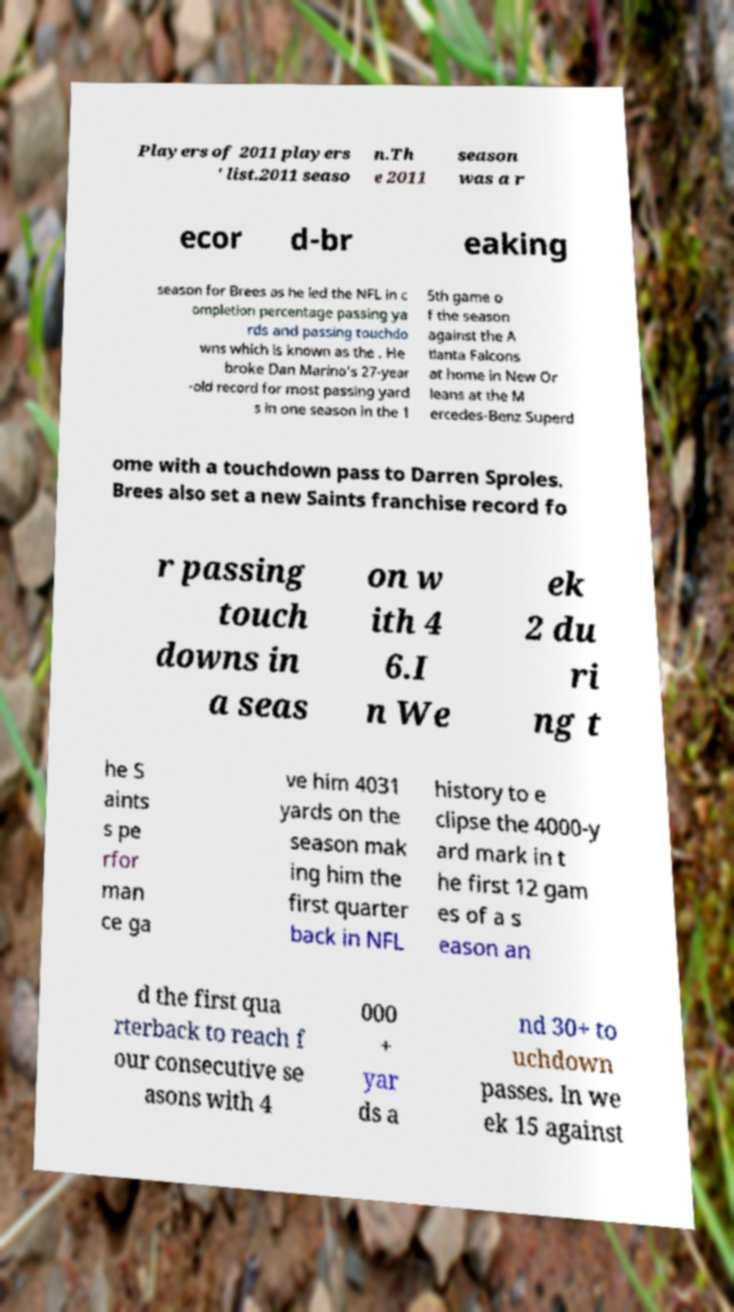What messages or text are displayed in this image? I need them in a readable, typed format. Players of 2011 players ' list.2011 seaso n.Th e 2011 season was a r ecor d-br eaking season for Brees as he led the NFL in c ompletion percentage passing ya rds and passing touchdo wns which is known as the . He broke Dan Marino's 27-year -old record for most passing yard s in one season in the 1 5th game o f the season against the A tlanta Falcons at home in New Or leans at the M ercedes-Benz Superd ome with a touchdown pass to Darren Sproles. Brees also set a new Saints franchise record fo r passing touch downs in a seas on w ith 4 6.I n We ek 2 du ri ng t he S aints s pe rfor man ce ga ve him 4031 yards on the season mak ing him the first quarter back in NFL history to e clipse the 4000-y ard mark in t he first 12 gam es of a s eason an d the first qua rterback to reach f our consecutive se asons with 4 000 + yar ds a nd 30+ to uchdown passes. In we ek 15 against 